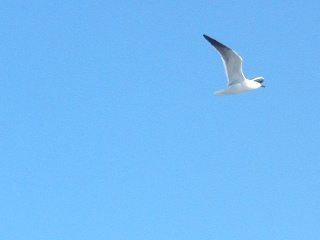What could be happening in the area that can't be seen in this image? Beyond the frame of this image, there might be a bustling beach filled with people enjoying the sunny weather, kids building sandcastles, and beachgoers lounging under colorful umbrellas. Alternatively, this bird could be part of a larger flock, making its way back to a coastal nest, with waves crashing rhythmically in the distance. 